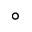<formula> <loc_0><loc_0><loc_500><loc_500>^ { \circ }</formula> 